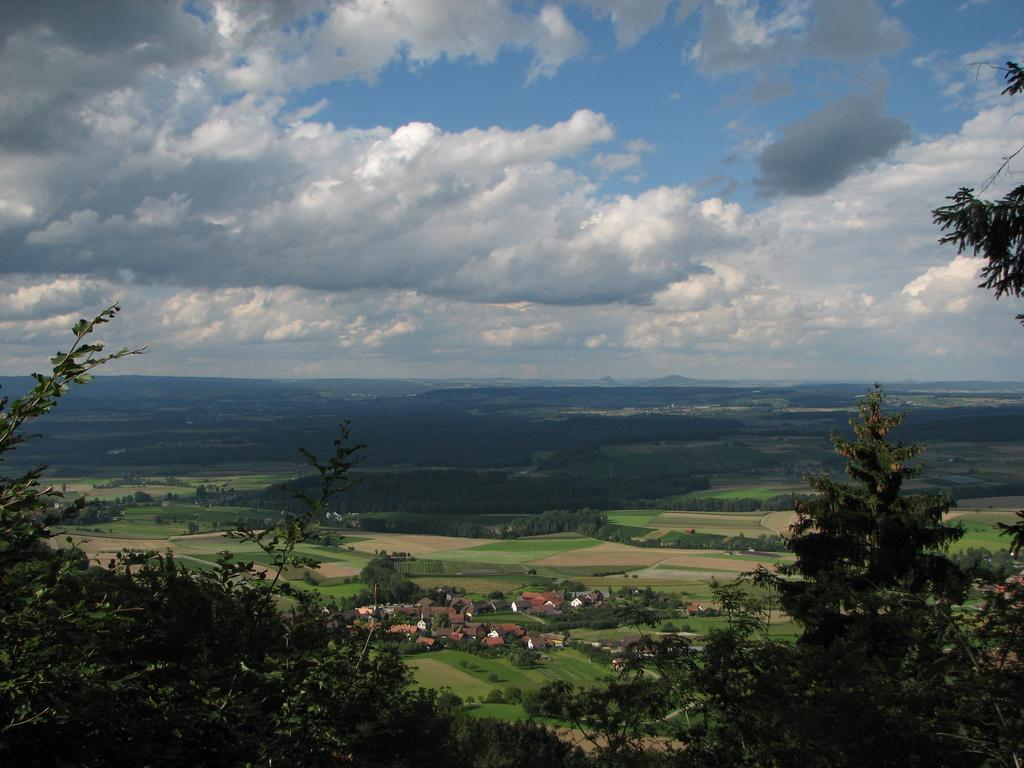What type of vegetation can be seen in the image? There are trees in the image. What is the color of the trees? The trees are green in color. What else can be seen on the ground in the image? There are buildings on the ground. What natural feature is visible in the distance? There are mountains in the image. What part of the environment is visible in the background? The sky is visible in the background of the image. What type of linen is draped over the mountains in the image? There is no linen draped over the mountains in the image; the mountains are visible in their natural state. 